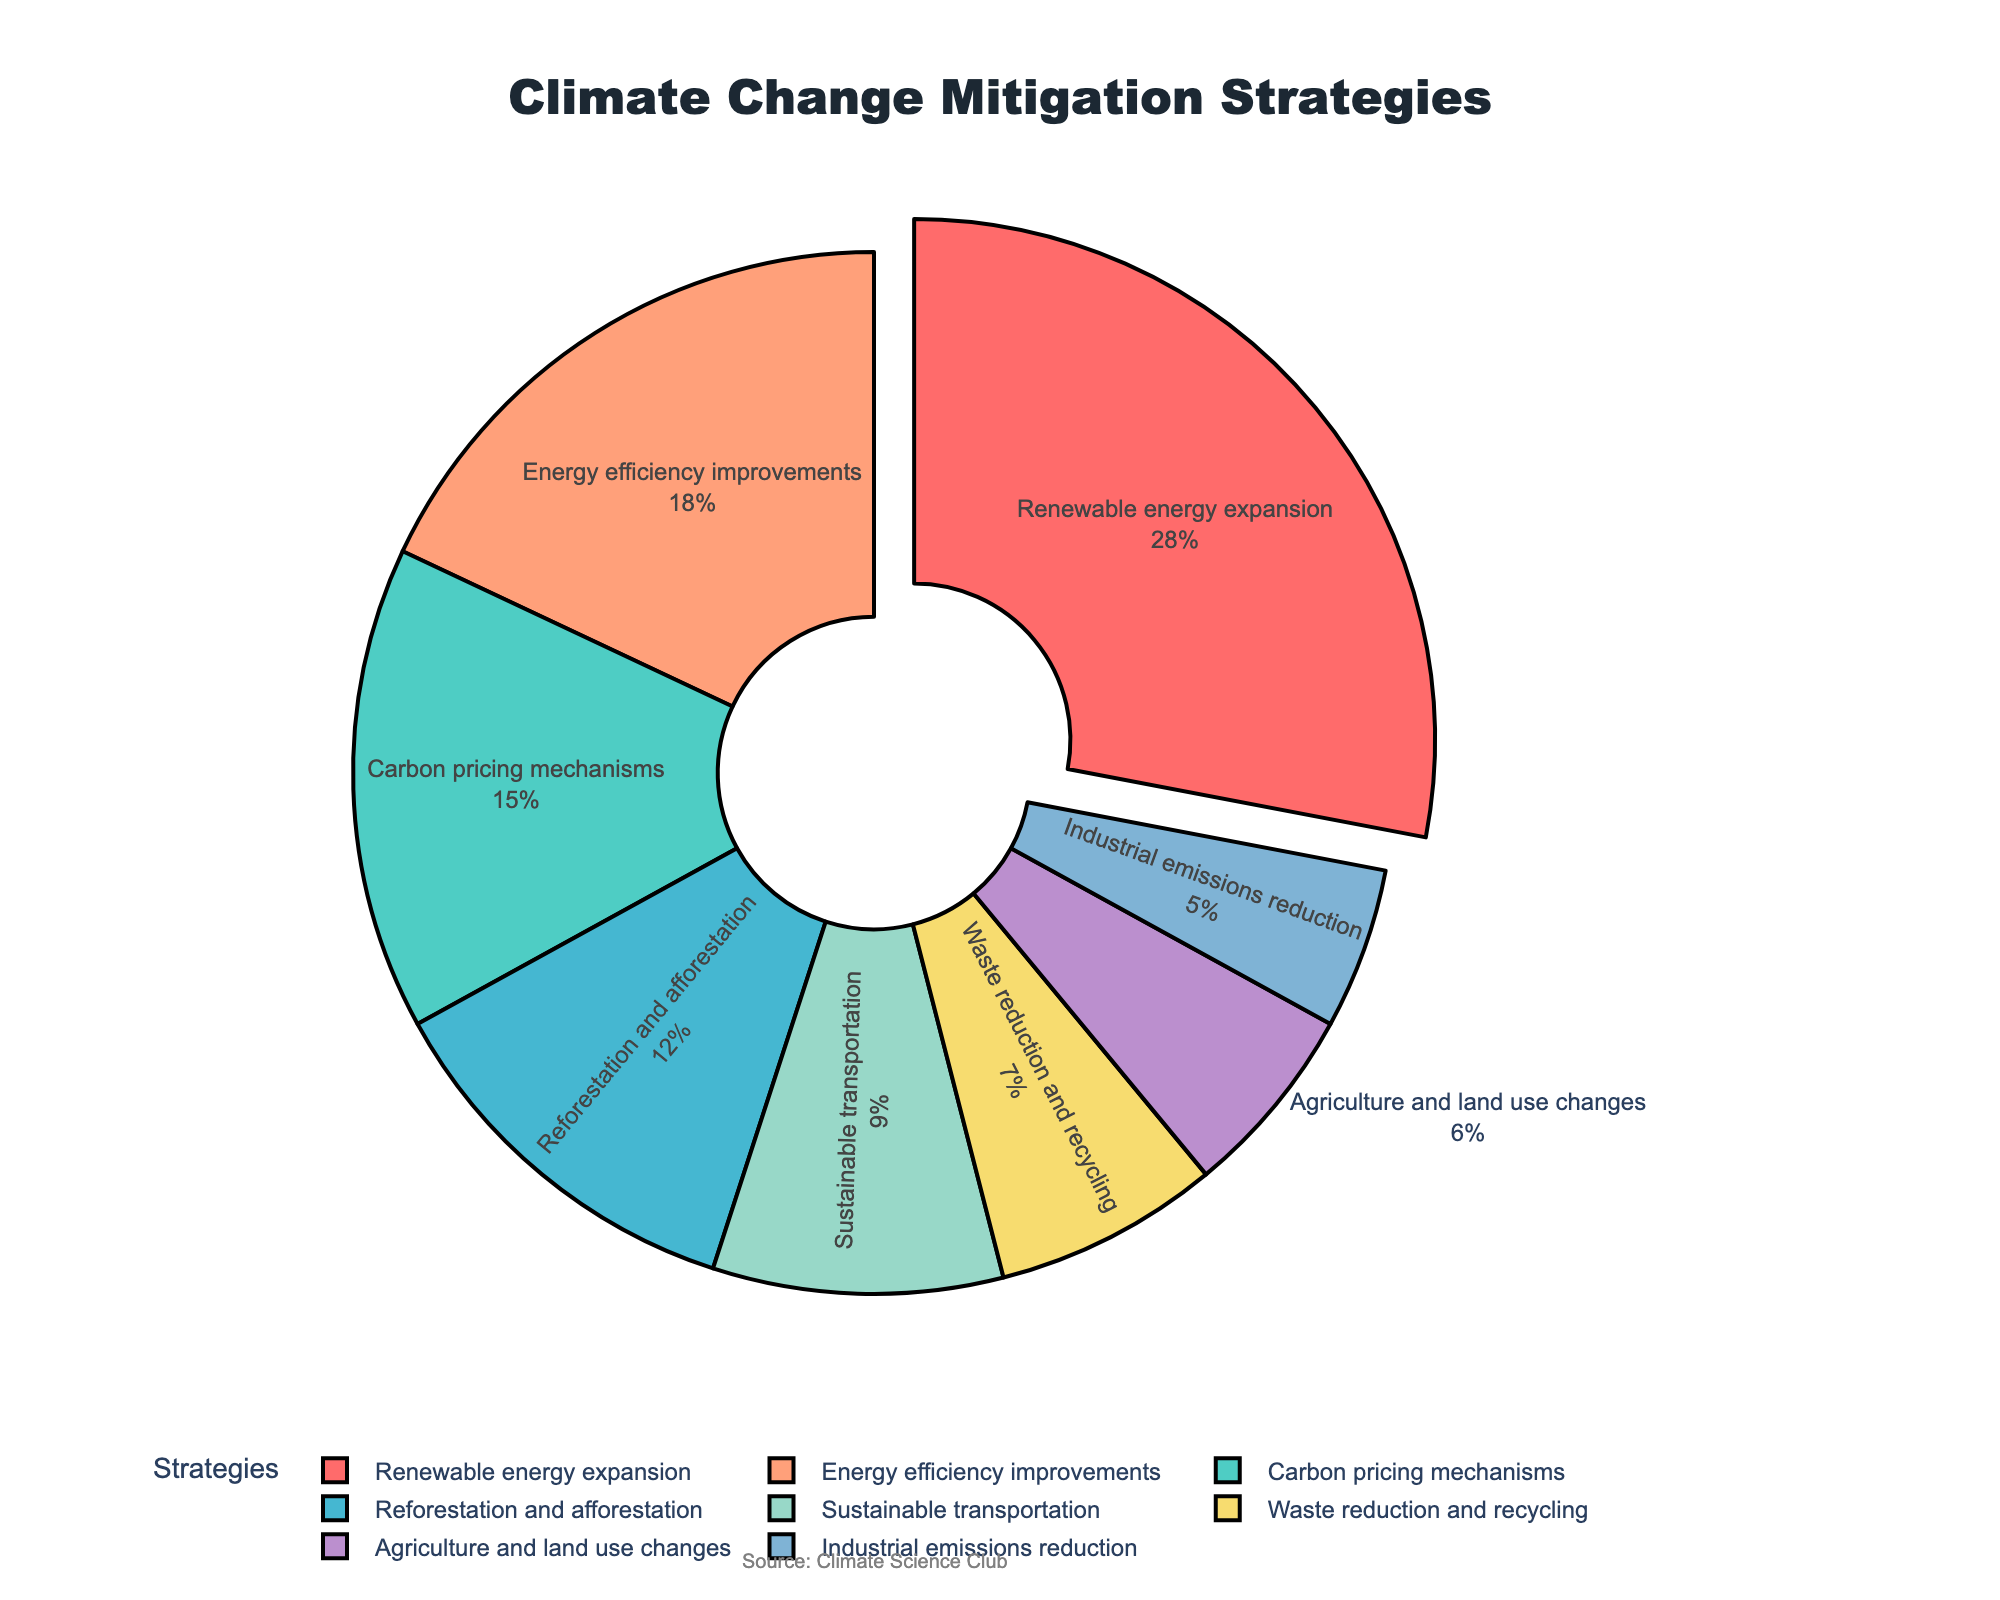What percentage of the strategies does Renewable energy expansion represent? Renewable energy expansion is one of the segments in the pie chart and it represents 28% of the total strategies.
Answer: 28% Which strategy has the least percentage share? By looking at the pie chart, Industrial emissions reduction has the smallest segment, indicating it has the least percentage share of 5%.
Answer: Industrial emissions reduction How many total strategies have a percentage share greater than 15%? The strategies with shares greater than 15% are Renewable energy expansion (28%) and Energy efficiency improvements (18%). That makes 2 strategies in total.
Answer: 2 strategies What is the combined percentage of strategies related to Renewable energy expansion and Energy efficiency improvements? Renewable energy expansion has 28% and Energy efficiency improvements has 18%. Adding these percentages together: 28% + 18% = 46%.
Answer: 46% By how much does the percentage for Carbon pricing mechanisms exceed that of Industrial emissions reduction? Carbon pricing mechanisms have a percentage of 15%, and Industrial emissions reduction has 5%. The difference is calculated as 15% - 5% = 10%.
Answer: 10% Which strategy section is displayed in red color? The Renewable energy expansion segment is the one shown in red color.
Answer: Renewable energy expansion Is the slice for Sustainable transportation larger or smaller than the slice for Waste reduction and recycling? Sustainable transportation has a percentage of 9%, while Waste reduction and recycling has 7%. Since 9% is greater than 7%, the slice for Sustainable transportation is larger.
Answer: Larger Can you identify a strategy that has a percentage between 5% and 10%? The strategies with percentage shares between 5% and 10% are Sustainable transportation with 9% and Waste reduction and recycling with 7%.
Answer: Sustainable transportation, Waste reduction and recycling What is the sum of the percentages of Reforestation and afforestation, Agriculture and land use changes, and Industrial emissions reduction? Reforestation and afforestation has 12%, Agriculture and land use changes has 6%, and Industrial emissions reduction has 5%. Summing these percentages: 12% + 6% + 5% = 23%.
Answer: 23% Which strategy is pulled out from the pie chart and why might this have been done? The Renewable energy expansion segment is pulled out from the pie chart, likely to highlight that it has the largest share at 28%.
Answer: Renewable energy expansion 